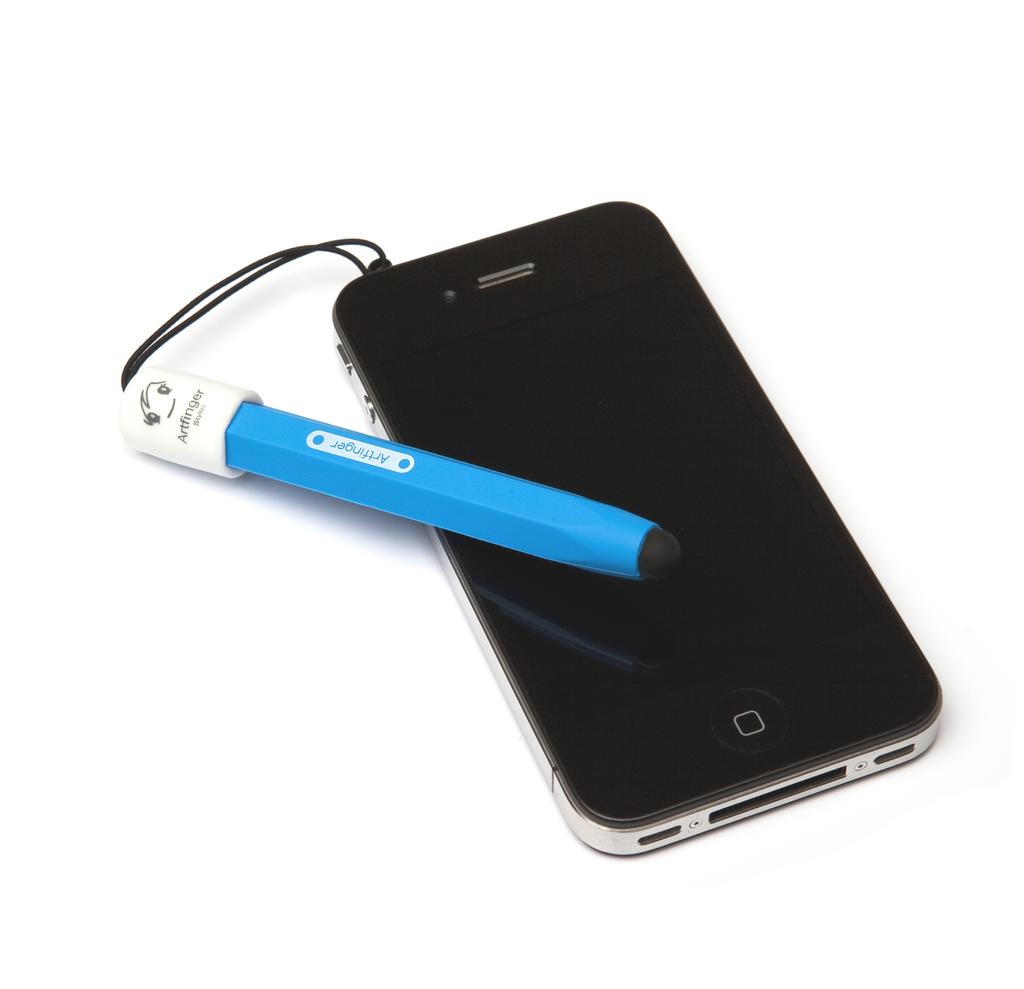Wow nice phone?
Offer a very short reply. Yes. 